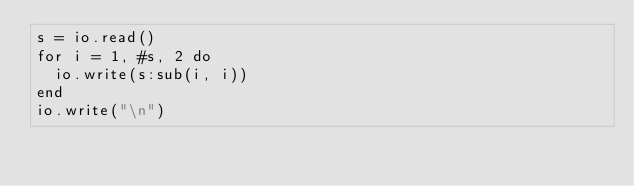Convert code to text. <code><loc_0><loc_0><loc_500><loc_500><_Lua_>s = io.read()
for i = 1, #s, 2 do
  io.write(s:sub(i, i))
end
io.write("\n")
</code> 